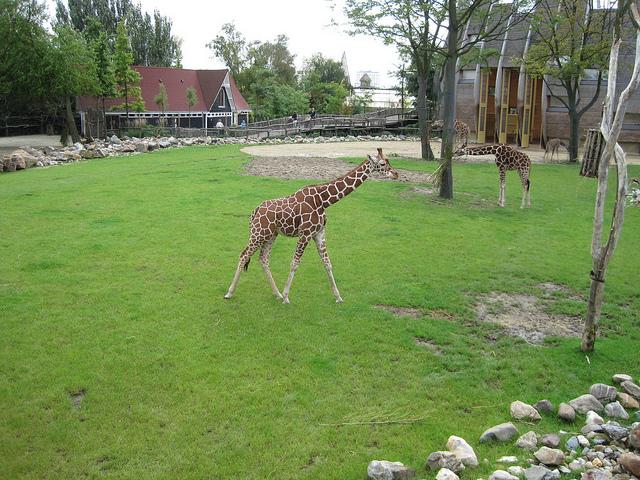What number of rocks are on the right?
Write a very short answer. 25. What is giraffe on far end doing?
Answer briefly. Eating. Are these giraffes in a zoo?
Give a very brief answer. Yes. 